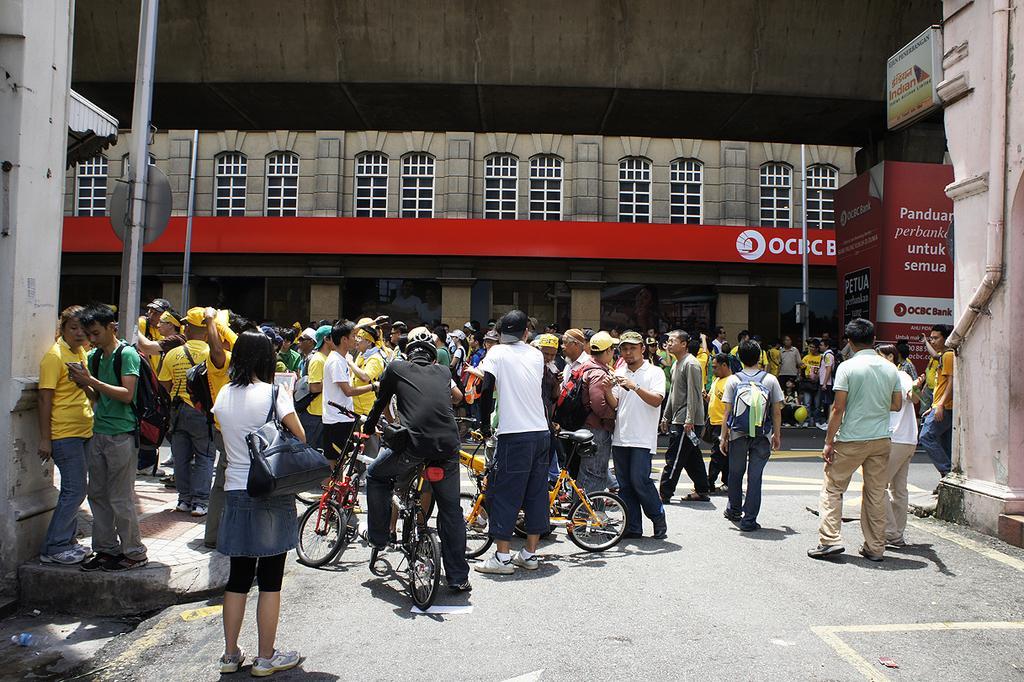Could you give a brief overview of what you see in this image? In this picture we can see a group of people where some are standing and some are walking on the road, bicycles, bags, caps, poles, pipe, posters, sun shade and in the background we can see buildings with windows. 